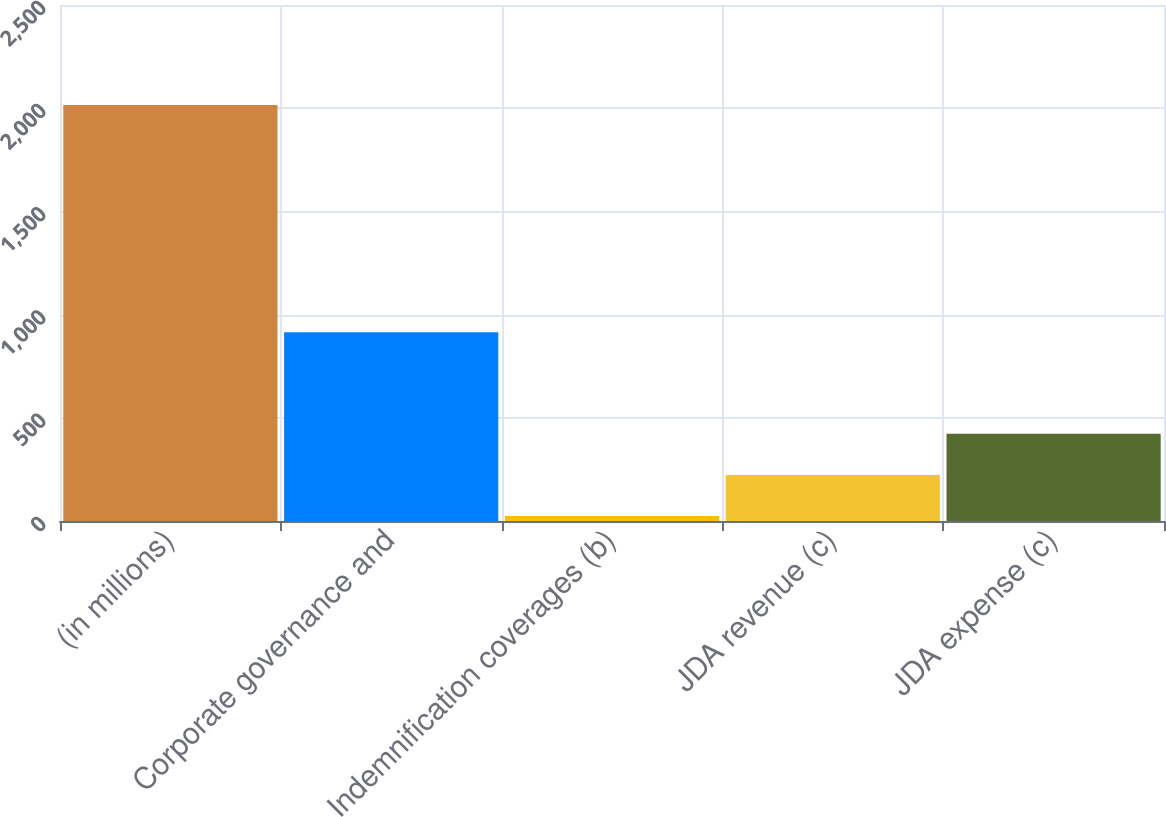Convert chart. <chart><loc_0><loc_0><loc_500><loc_500><bar_chart><fcel>(in millions)<fcel>Corporate governance and<fcel>Indemnification coverages (b)<fcel>JDA revenue (c)<fcel>JDA expense (c)<nl><fcel>2015<fcel>914<fcel>24<fcel>223.1<fcel>422.2<nl></chart> 